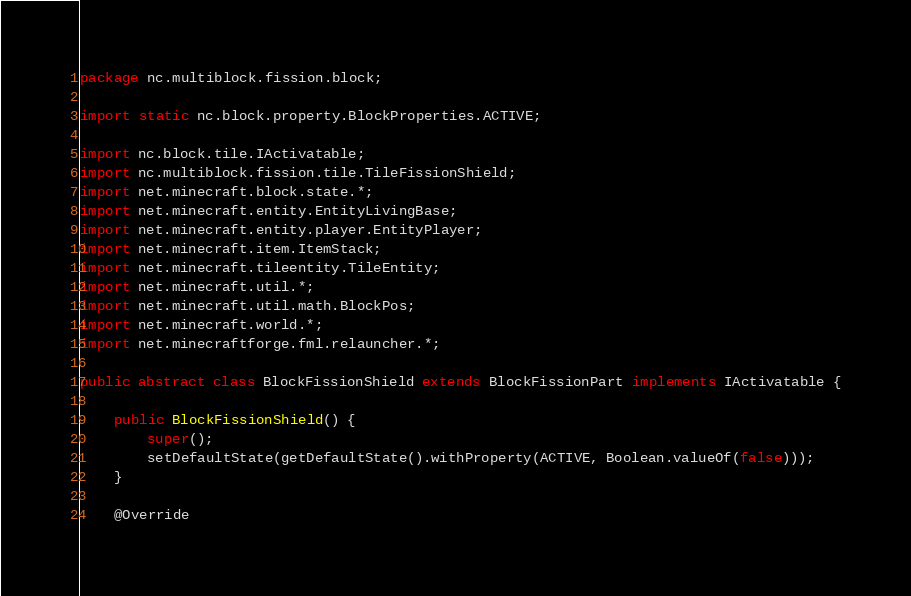Convert code to text. <code><loc_0><loc_0><loc_500><loc_500><_Java_>package nc.multiblock.fission.block;

import static nc.block.property.BlockProperties.ACTIVE;

import nc.block.tile.IActivatable;
import nc.multiblock.fission.tile.TileFissionShield;
import net.minecraft.block.state.*;
import net.minecraft.entity.EntityLivingBase;
import net.minecraft.entity.player.EntityPlayer;
import net.minecraft.item.ItemStack;
import net.minecraft.tileentity.TileEntity;
import net.minecraft.util.*;
import net.minecraft.util.math.BlockPos;
import net.minecraft.world.*;
import net.minecraftforge.fml.relauncher.*;

public abstract class BlockFissionShield extends BlockFissionPart implements IActivatable {
	
	public BlockFissionShield() {
		super();
		setDefaultState(getDefaultState().withProperty(ACTIVE, Boolean.valueOf(false)));
	}
	
	@Override</code> 